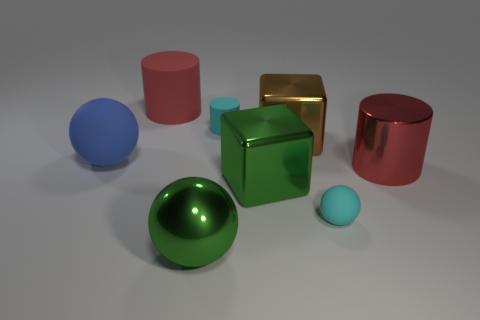Add 1 large brown cylinders. How many objects exist? 9 Subtract all blocks. How many objects are left? 6 Subtract all big cyan metallic things. Subtract all spheres. How many objects are left? 5 Add 8 shiny cylinders. How many shiny cylinders are left? 9 Add 3 shiny balls. How many shiny balls exist? 4 Subtract 0 gray cylinders. How many objects are left? 8 